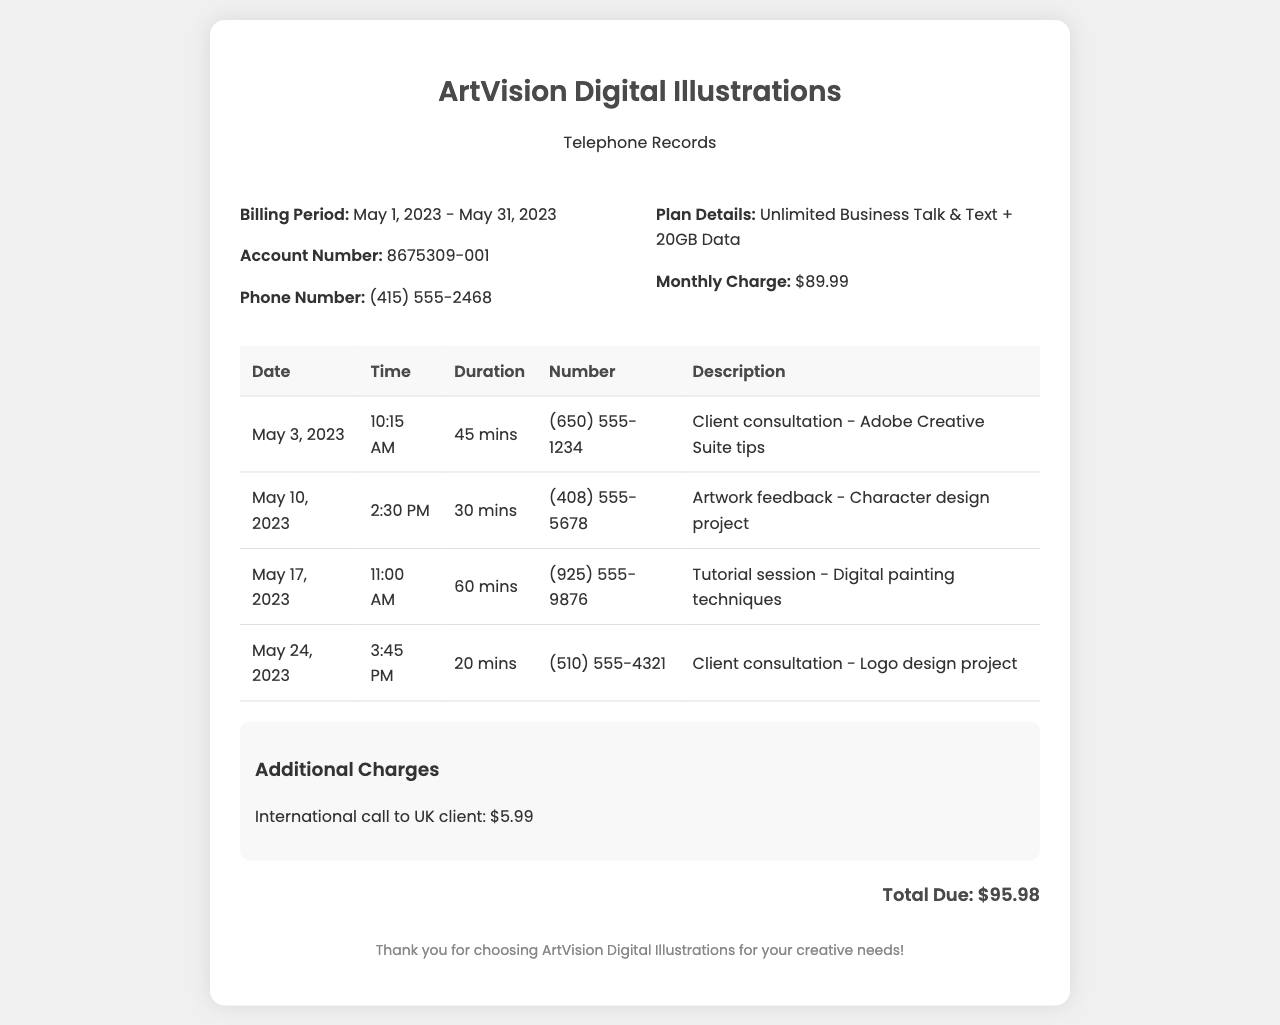what is the billing period? The billing period is clearly mentioned in the document as from May 1, 2023 to May 31, 2023.
Answer: May 1, 2023 - May 31, 2023 what is the monthly charge? The monthly charge for the unlimited business plan in the document is mentioned.
Answer: $89.99 how long was the longest call? By reviewing the call durations, the longest duration is for the tutorial session at 60 minutes.
Answer: 60 mins how many client consultations are listed? The document contains a summary of client consultations, and there are a total of 3 listed.
Answer: 3 what is the total due amount? The total due amount is provided in the document as the sum of all charges.
Answer: $95.98 what type of plan is used? The document specifies the type of service plan for the business line.
Answer: Unlimited Business Talk & Text + 20GB Data how many calls occurred after May 15? A quick review of dates shows that 2 calls occurred after May 15, 2023.
Answer: 2 what was the purpose of the call on May 10? The call on May 10 is described for a specific feedback session project.
Answer: Artwork feedback - Character design project how much was charged for the international call? The document clearly outlines a specific charge for an international call.
Answer: $5.99 